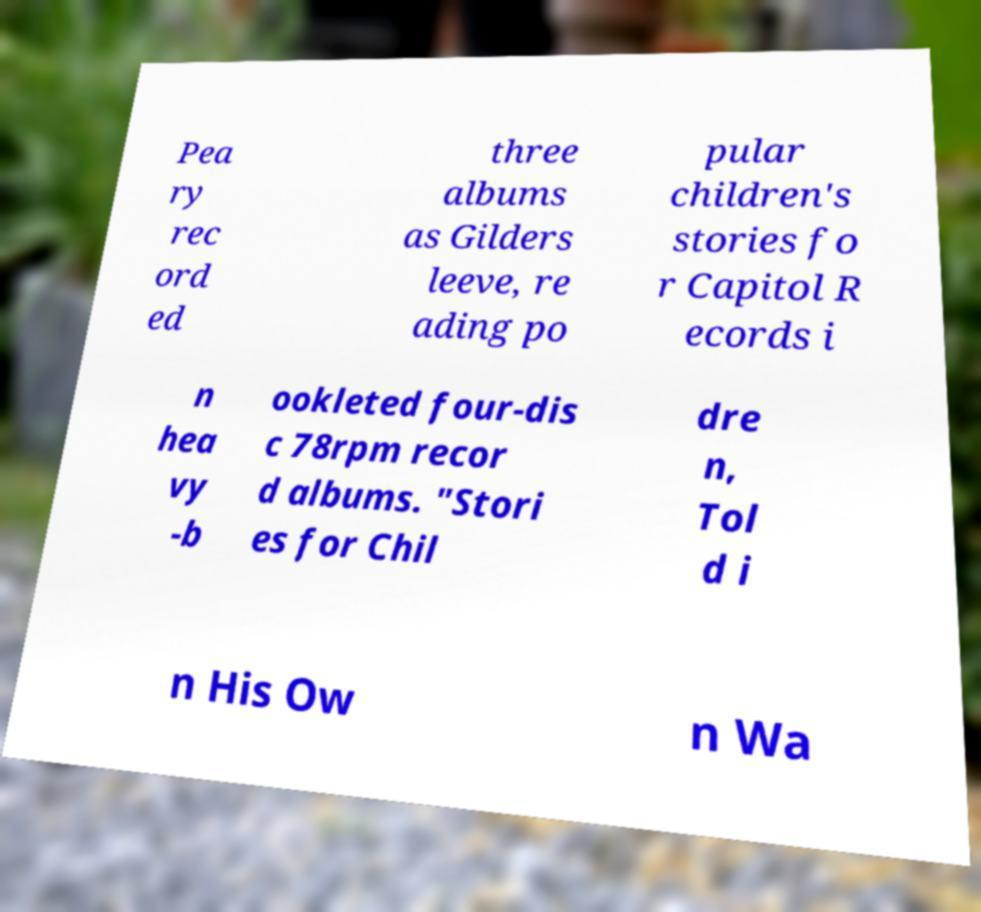I need the written content from this picture converted into text. Can you do that? Pea ry rec ord ed three albums as Gilders leeve, re ading po pular children's stories fo r Capitol R ecords i n hea vy -b ookleted four-dis c 78rpm recor d albums. "Stori es for Chil dre n, Tol d i n His Ow n Wa 